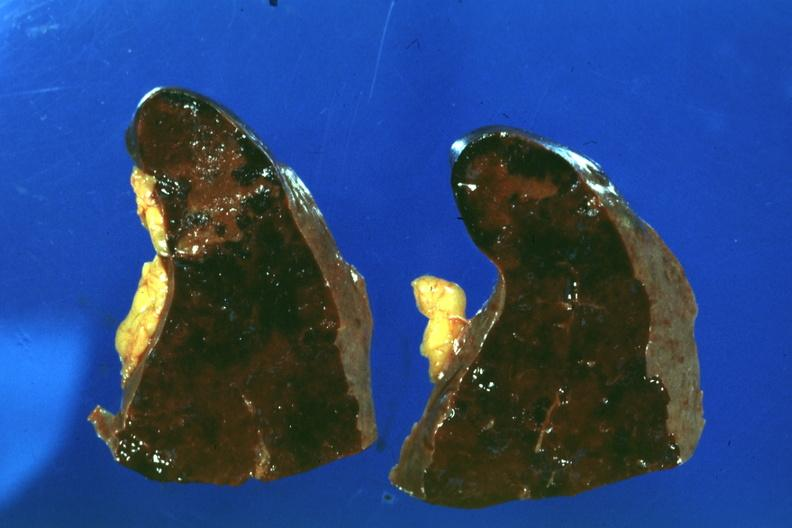what is present?
Answer the question using a single word or phrase. Hematologic 